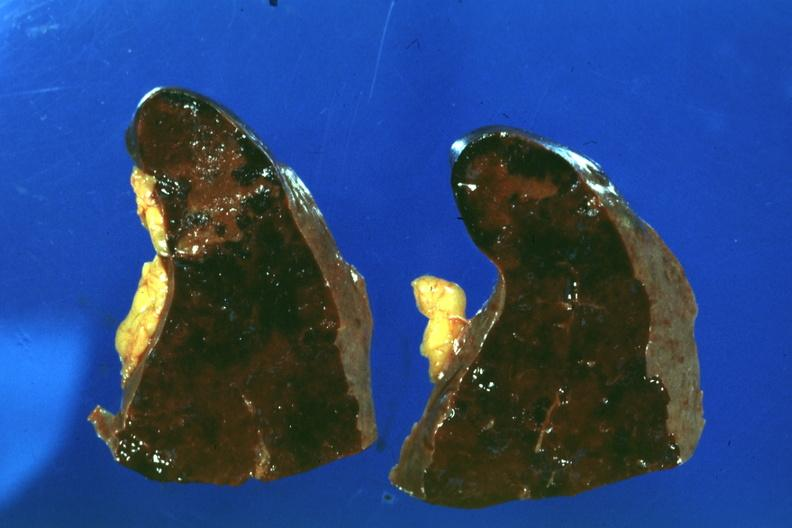what is present?
Answer the question using a single word or phrase. Hematologic 